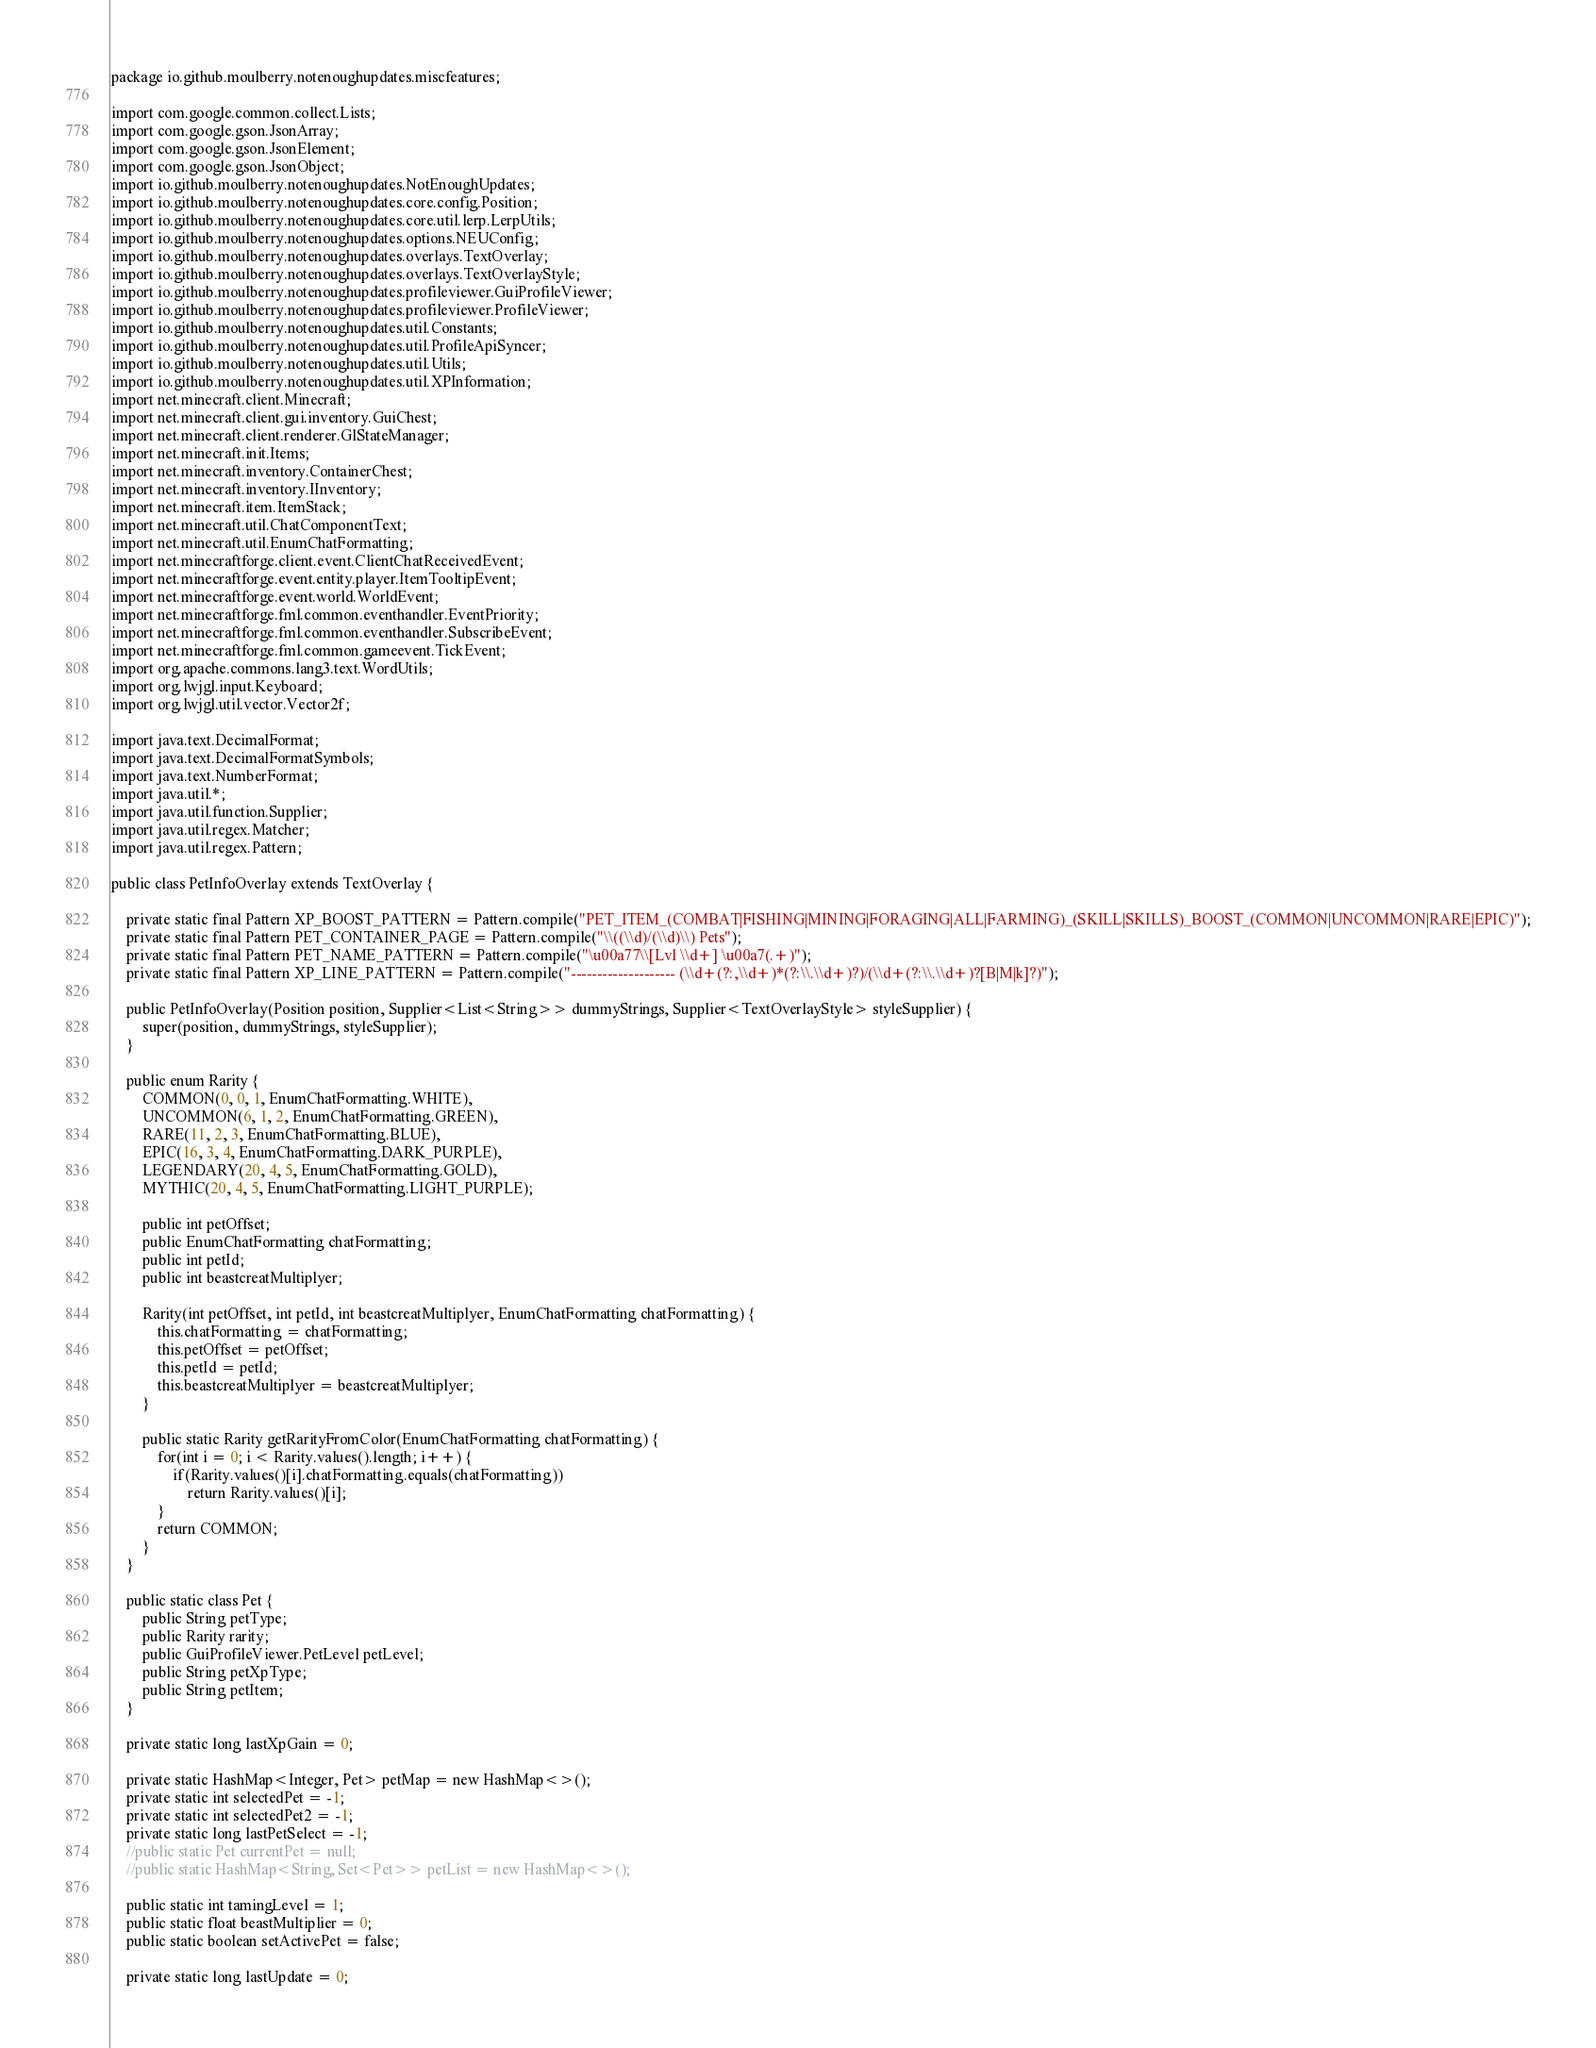Convert code to text. <code><loc_0><loc_0><loc_500><loc_500><_Java_>package io.github.moulberry.notenoughupdates.miscfeatures;

import com.google.common.collect.Lists;
import com.google.gson.JsonArray;
import com.google.gson.JsonElement;
import com.google.gson.JsonObject;
import io.github.moulberry.notenoughupdates.NotEnoughUpdates;
import io.github.moulberry.notenoughupdates.core.config.Position;
import io.github.moulberry.notenoughupdates.core.util.lerp.LerpUtils;
import io.github.moulberry.notenoughupdates.options.NEUConfig;
import io.github.moulberry.notenoughupdates.overlays.TextOverlay;
import io.github.moulberry.notenoughupdates.overlays.TextOverlayStyle;
import io.github.moulberry.notenoughupdates.profileviewer.GuiProfileViewer;
import io.github.moulberry.notenoughupdates.profileviewer.ProfileViewer;
import io.github.moulberry.notenoughupdates.util.Constants;
import io.github.moulberry.notenoughupdates.util.ProfileApiSyncer;
import io.github.moulberry.notenoughupdates.util.Utils;
import io.github.moulberry.notenoughupdates.util.XPInformation;
import net.minecraft.client.Minecraft;
import net.minecraft.client.gui.inventory.GuiChest;
import net.minecraft.client.renderer.GlStateManager;
import net.minecraft.init.Items;
import net.minecraft.inventory.ContainerChest;
import net.minecraft.inventory.IInventory;
import net.minecraft.item.ItemStack;
import net.minecraft.util.ChatComponentText;
import net.minecraft.util.EnumChatFormatting;
import net.minecraftforge.client.event.ClientChatReceivedEvent;
import net.minecraftforge.event.entity.player.ItemTooltipEvent;
import net.minecraftforge.event.world.WorldEvent;
import net.minecraftforge.fml.common.eventhandler.EventPriority;
import net.minecraftforge.fml.common.eventhandler.SubscribeEvent;
import net.minecraftforge.fml.common.gameevent.TickEvent;
import org.apache.commons.lang3.text.WordUtils;
import org.lwjgl.input.Keyboard;
import org.lwjgl.util.vector.Vector2f;

import java.text.DecimalFormat;
import java.text.DecimalFormatSymbols;
import java.text.NumberFormat;
import java.util.*;
import java.util.function.Supplier;
import java.util.regex.Matcher;
import java.util.regex.Pattern;

public class PetInfoOverlay extends TextOverlay {

    private static final Pattern XP_BOOST_PATTERN = Pattern.compile("PET_ITEM_(COMBAT|FISHING|MINING|FORAGING|ALL|FARMING)_(SKILL|SKILLS)_BOOST_(COMMON|UNCOMMON|RARE|EPIC)");
    private static final Pattern PET_CONTAINER_PAGE = Pattern.compile("\\((\\d)/(\\d)\\) Pets");
    private static final Pattern PET_NAME_PATTERN = Pattern.compile("\u00a77\\[Lvl \\d+] \u00a7(.+)");
    private static final Pattern XP_LINE_PATTERN = Pattern.compile("-------------------- (\\d+(?:,\\d+)*(?:\\.\\d+)?)/(\\d+(?:\\.\\d+)?[B|M|k]?)");

    public PetInfoOverlay(Position position, Supplier<List<String>> dummyStrings, Supplier<TextOverlayStyle> styleSupplier) {
        super(position, dummyStrings, styleSupplier);
    }

    public enum Rarity {
        COMMON(0, 0, 1, EnumChatFormatting.WHITE),
        UNCOMMON(6, 1, 2, EnumChatFormatting.GREEN),
        RARE(11, 2, 3, EnumChatFormatting.BLUE),
        EPIC(16, 3, 4, EnumChatFormatting.DARK_PURPLE),
        LEGENDARY(20, 4, 5, EnumChatFormatting.GOLD),
        MYTHIC(20, 4, 5, EnumChatFormatting.LIGHT_PURPLE);

        public int petOffset;
        public EnumChatFormatting chatFormatting;
        public int petId;
        public int beastcreatMultiplyer;

        Rarity(int petOffset, int petId, int beastcreatMultiplyer, EnumChatFormatting chatFormatting) {
            this.chatFormatting = chatFormatting;
            this.petOffset = petOffset;
            this.petId = petId;
            this.beastcreatMultiplyer = beastcreatMultiplyer;
        }

        public static Rarity getRarityFromColor(EnumChatFormatting chatFormatting) {
            for(int i = 0; i < Rarity.values().length; i++) {
                if(Rarity.values()[i].chatFormatting.equals(chatFormatting))
                    return Rarity.values()[i];
            }
            return COMMON;
        }
    }

    public static class Pet {
        public String petType;
        public Rarity rarity;
        public GuiProfileViewer.PetLevel petLevel;
        public String petXpType;
        public String petItem;
    }

    private static long lastXpGain = 0;

    private static HashMap<Integer, Pet> petMap = new HashMap<>();
    private static int selectedPet = -1;
    private static int selectedPet2 = -1;
    private static long lastPetSelect = -1;
    //public static Pet currentPet = null;
    //public static HashMap<String, Set<Pet>> petList = new HashMap<>();

    public static int tamingLevel = 1;
    public static float beastMultiplier = 0;
    public static boolean setActivePet = false;

    private static long lastUpdate = 0;</code> 